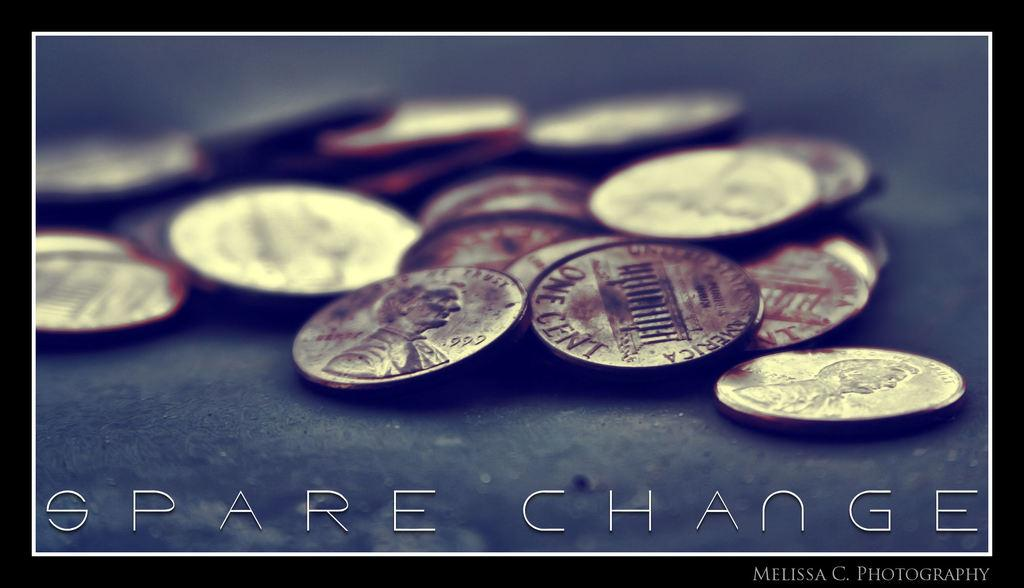<image>
Render a clear and concise summary of the photo. the words spare change are next to the money 